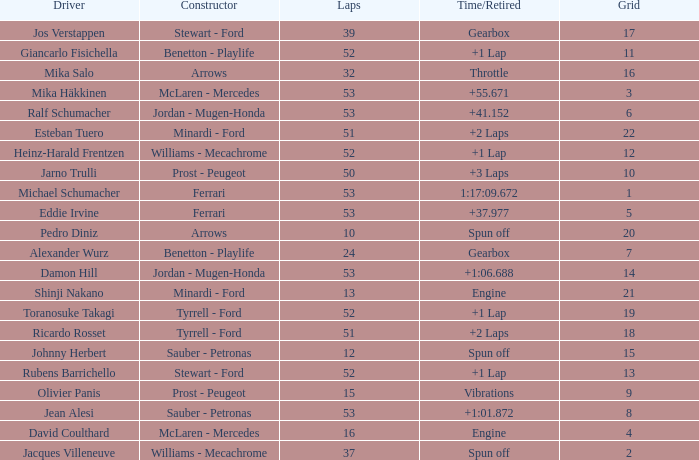What is the high lap total for pedro diniz? 10.0. 